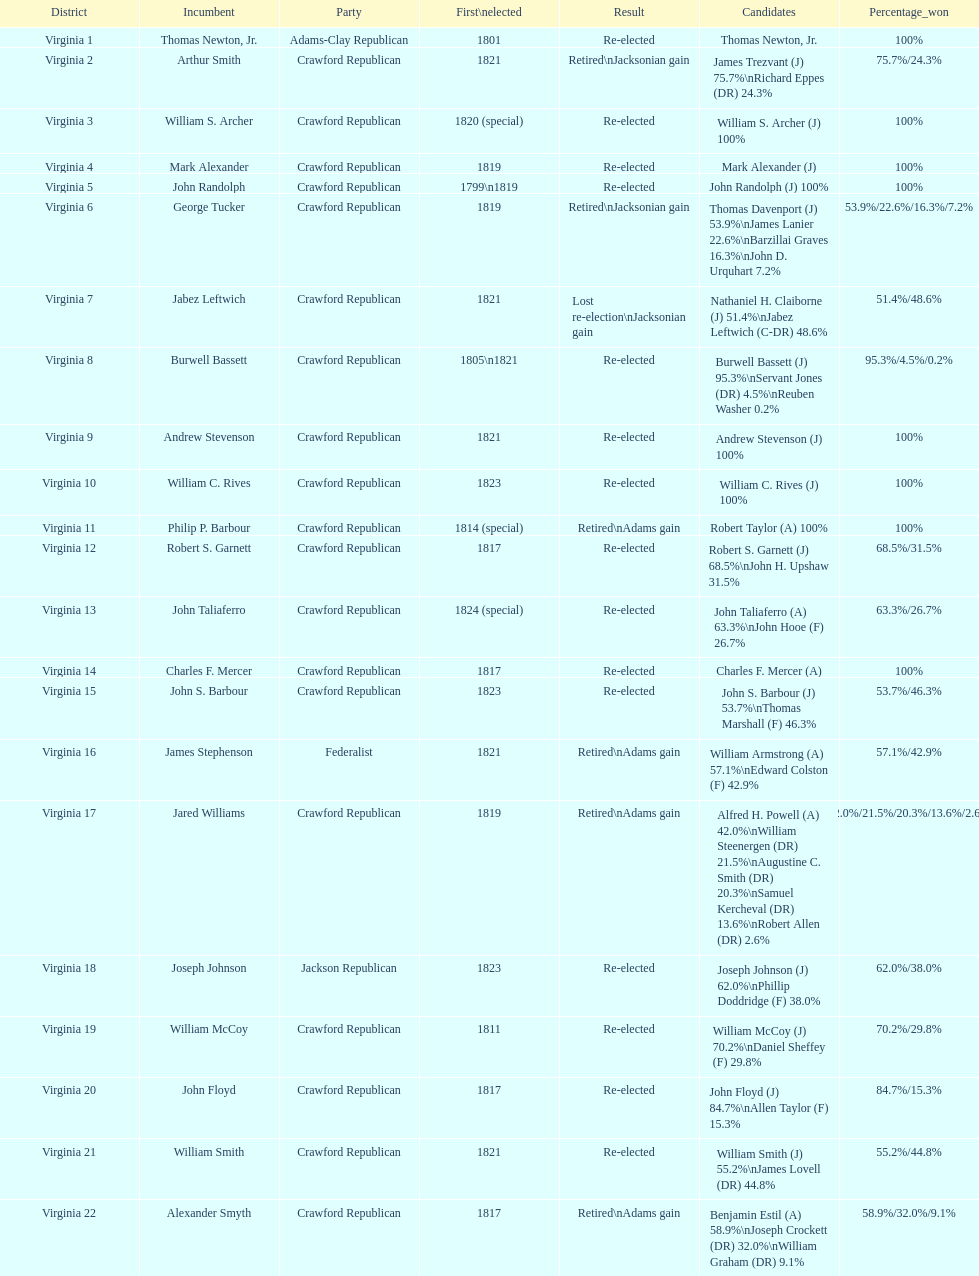How many candidates were there for virginia 17 district? 5. 